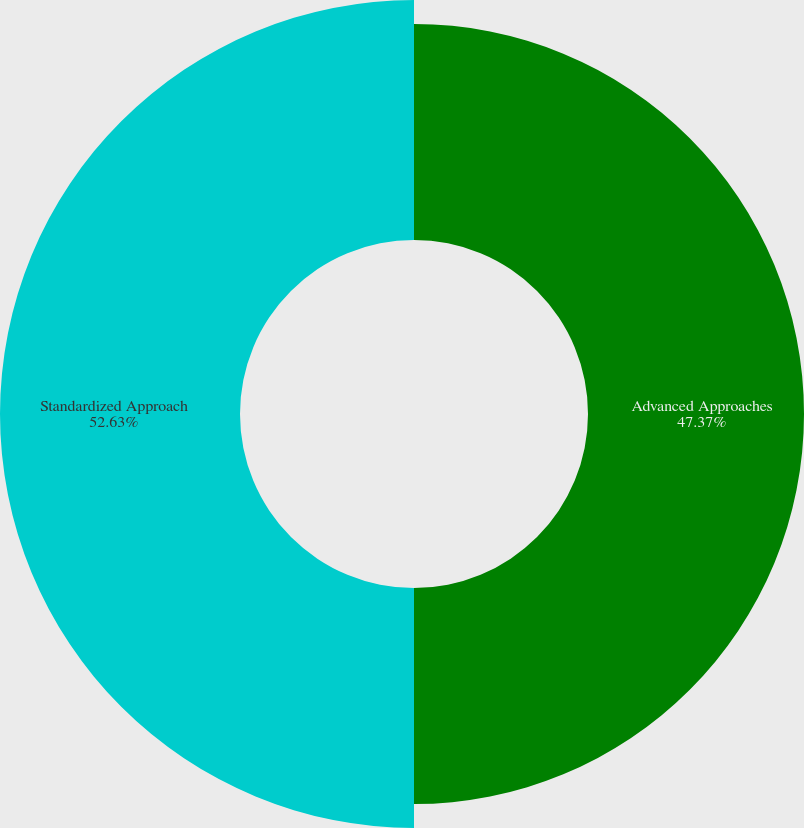Convert chart to OTSL. <chart><loc_0><loc_0><loc_500><loc_500><pie_chart><fcel>Advanced Approaches<fcel>Standardized Approach<nl><fcel>47.37%<fcel>52.63%<nl></chart> 